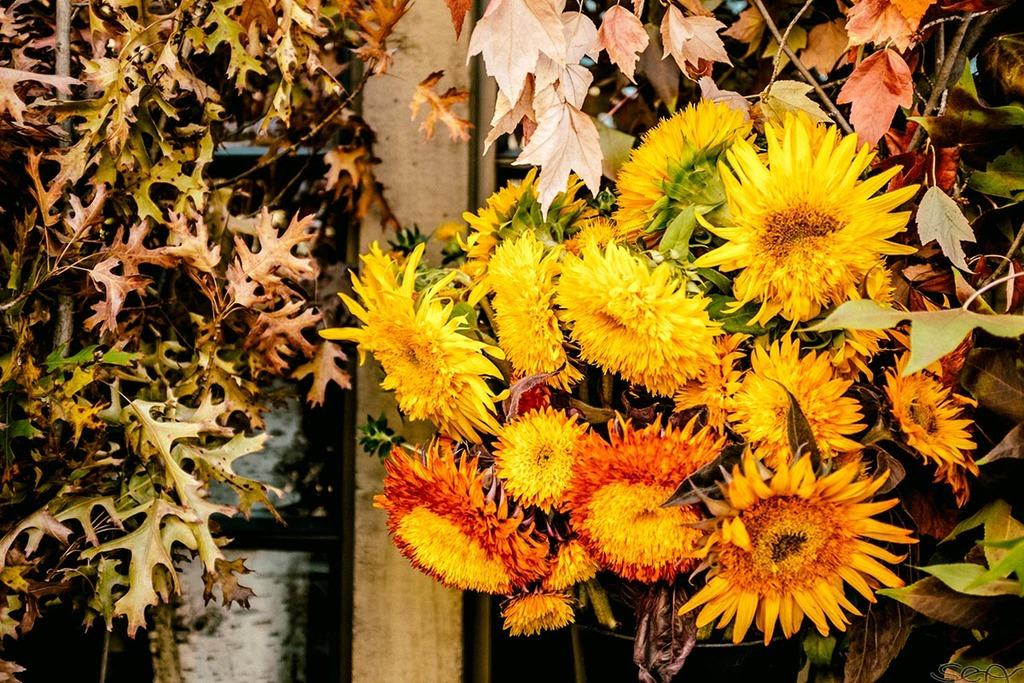What is the main subject of the image? The main subject of the image is a bunch of flowers. What color are the flowers? The flowers are yellow in color. Are there any other parts of the plant visible in the image? Yes, there are leaves associated with the flowers. What can be seen in the background of the image? There is a wooden pillar in the background of the image. How many giraffes are standing next to the wooden pillar in the image? There are no giraffes present in the image; it features a bunch of yellow flowers with leaves and a wooden pillar in the background. 